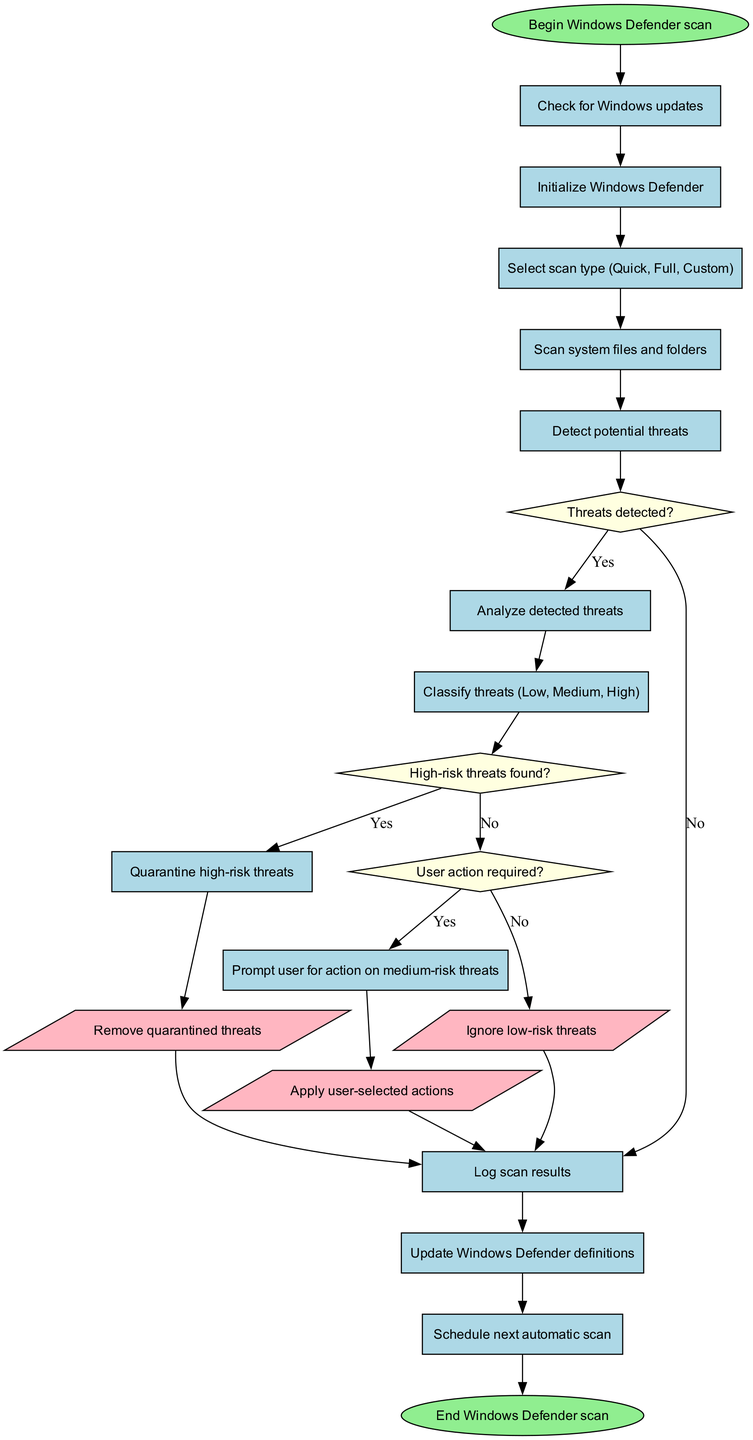What is the first step in the Windows Defender scan? The flowchart shows the first step as "Begin Windows Defender scan," which indicates the initiation of the entire scanning process.
Answer: Begin Windows Defender scan How many decision nodes are present in the diagram? By examining the flowchart, there are three decision nodes: "Threats detected?", "High-risk threats found?", and "User action required?". Therefore, the total is three.
Answer: 3 What happens if high-risk threats are found? The flowchart indicates that upon finding high-risk threats, the next action is to "Quarantine high-risk threats," which indicates a precautionary measure before any user action.
Answer: Quarantine high-risk threats What action follows if no threats are detected? If no threats are detected according to the "Threats detected?" decision node, the flowchart directs to "Log scan results," which indicates documentation of the scan's findings.
Answer: Log scan results If the user selects an action on medium-risk threats, what is the next step? The flowchart indicates that if the user takes action on medium-risk threats, the subsequent step is to "Apply user-selected actions." Thus, this action directly follows the user's choice.
Answer: Apply user-selected actions What is the last action before ending the scan? The final action indicated in the flowchart before concluding the process is "Schedule next automatic scan," which suggests preparation for future scans.
Answer: Schedule next automatic scan What type of scan can the user choose? The flowchart lists that the user can select from three types of scans: Quick, Full, and Custom, which provides options based on the desired depth of the scan.
Answer: Quick, Full, Custom What color represents action nodes in the flowchart? The flowchart specifies action nodes are shown in light pink, indicating a distinct visual style for actions that require user or system activities.
Answer: Light pink 